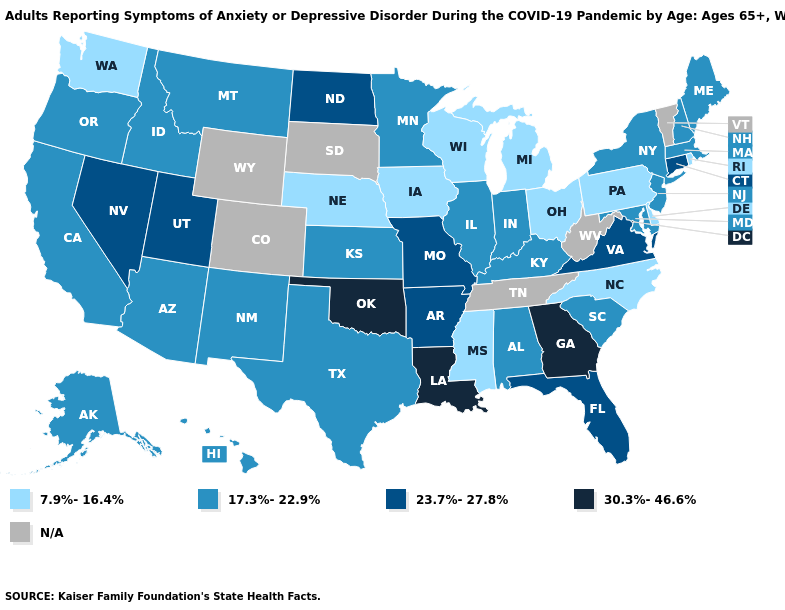Name the states that have a value in the range N/A?
Give a very brief answer. Colorado, South Dakota, Tennessee, Vermont, West Virginia, Wyoming. Name the states that have a value in the range 30.3%-46.6%?
Write a very short answer. Georgia, Louisiana, Oklahoma. Name the states that have a value in the range 23.7%-27.8%?
Give a very brief answer. Arkansas, Connecticut, Florida, Missouri, Nevada, North Dakota, Utah, Virginia. Name the states that have a value in the range 17.3%-22.9%?
Keep it brief. Alabama, Alaska, Arizona, California, Hawaii, Idaho, Illinois, Indiana, Kansas, Kentucky, Maine, Maryland, Massachusetts, Minnesota, Montana, New Hampshire, New Jersey, New Mexico, New York, Oregon, South Carolina, Texas. Name the states that have a value in the range N/A?
Be succinct. Colorado, South Dakota, Tennessee, Vermont, West Virginia, Wyoming. What is the highest value in the MidWest ?
Give a very brief answer. 23.7%-27.8%. What is the value of Nebraska?
Write a very short answer. 7.9%-16.4%. What is the value of Maryland?
Quick response, please. 17.3%-22.9%. Name the states that have a value in the range 30.3%-46.6%?
Concise answer only. Georgia, Louisiana, Oklahoma. Name the states that have a value in the range 17.3%-22.9%?
Be succinct. Alabama, Alaska, Arizona, California, Hawaii, Idaho, Illinois, Indiana, Kansas, Kentucky, Maine, Maryland, Massachusetts, Minnesota, Montana, New Hampshire, New Jersey, New Mexico, New York, Oregon, South Carolina, Texas. Is the legend a continuous bar?
Keep it brief. No. Among the states that border Idaho , does Utah have the highest value?
Keep it brief. Yes. Does the first symbol in the legend represent the smallest category?
Answer briefly. Yes. Which states have the lowest value in the MidWest?
Short answer required. Iowa, Michigan, Nebraska, Ohio, Wisconsin. 